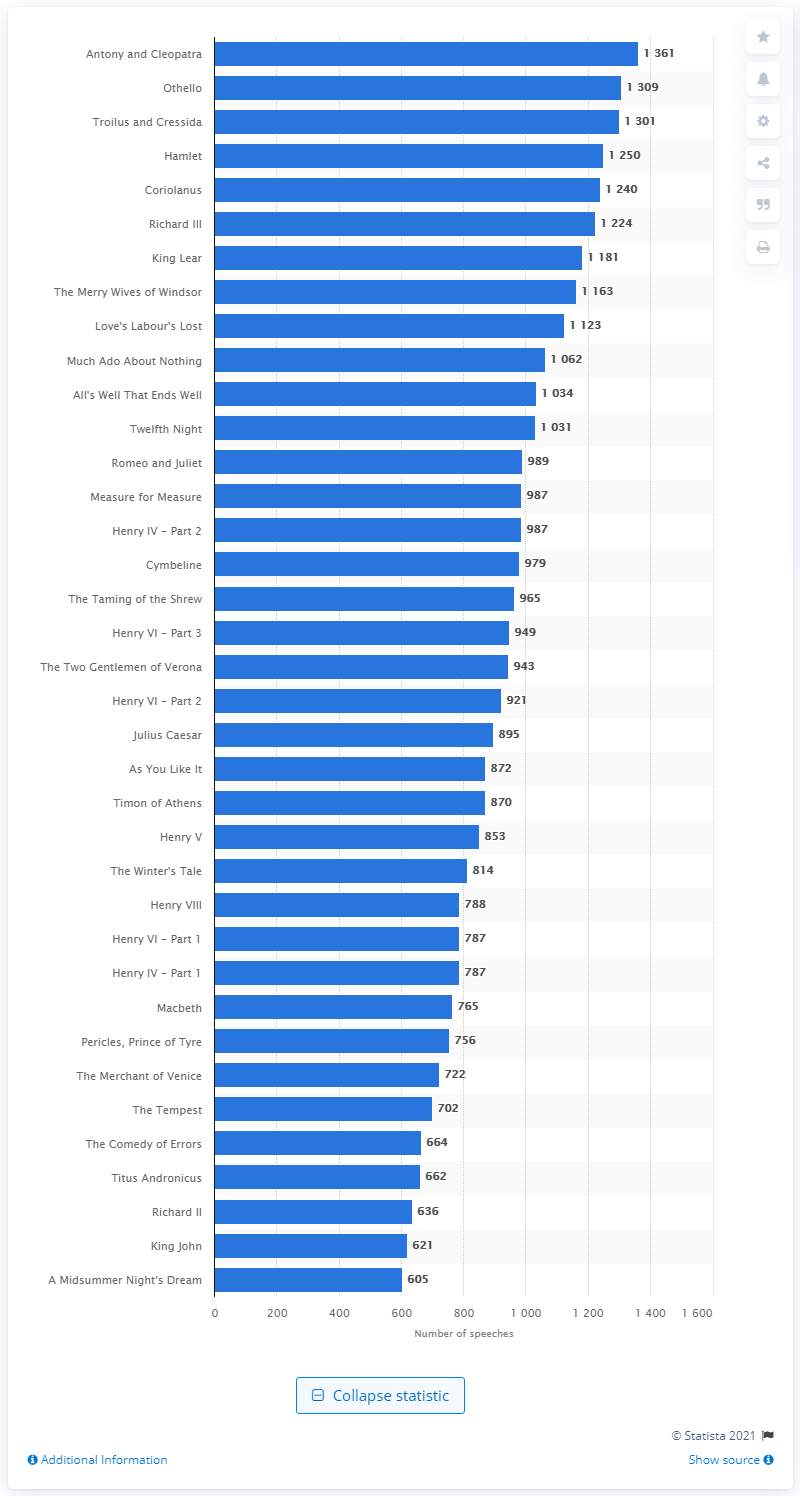Identify some key points in this picture. Hamlet, a Shakespeare play, has the highest word count among all his works. Antony and Cleopatra have 1309 speeches. The Comedy of Errors is the Shakespeare play with the lowest word count. 